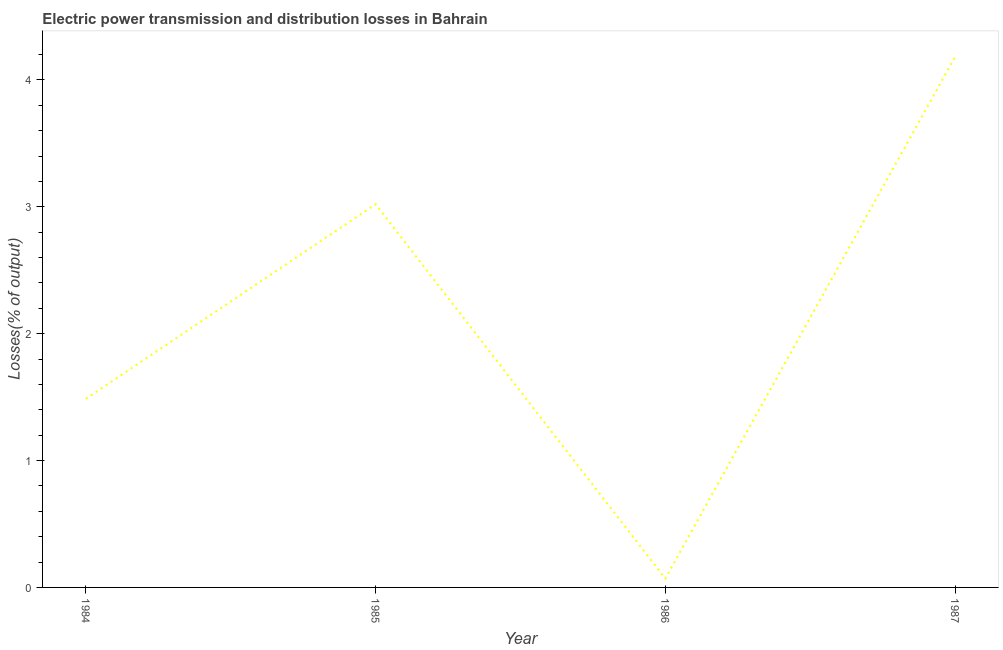What is the electric power transmission and distribution losses in 1984?
Your response must be concise. 1.49. Across all years, what is the maximum electric power transmission and distribution losses?
Provide a succinct answer. 4.18. Across all years, what is the minimum electric power transmission and distribution losses?
Offer a terse response. 0.07. In which year was the electric power transmission and distribution losses maximum?
Your response must be concise. 1987. In which year was the electric power transmission and distribution losses minimum?
Provide a short and direct response. 1986. What is the sum of the electric power transmission and distribution losses?
Your response must be concise. 8.76. What is the difference between the electric power transmission and distribution losses in 1984 and 1985?
Offer a terse response. -1.53. What is the average electric power transmission and distribution losses per year?
Your answer should be compact. 2.19. What is the median electric power transmission and distribution losses?
Keep it short and to the point. 2.25. In how many years, is the electric power transmission and distribution losses greater than 2.6 %?
Give a very brief answer. 2. What is the ratio of the electric power transmission and distribution losses in 1985 to that in 1987?
Offer a terse response. 0.72. Is the difference between the electric power transmission and distribution losses in 1985 and 1986 greater than the difference between any two years?
Your response must be concise. No. What is the difference between the highest and the second highest electric power transmission and distribution losses?
Your answer should be compact. 1.16. Is the sum of the electric power transmission and distribution losses in 1984 and 1986 greater than the maximum electric power transmission and distribution losses across all years?
Provide a short and direct response. No. What is the difference between the highest and the lowest electric power transmission and distribution losses?
Your answer should be very brief. 4.11. In how many years, is the electric power transmission and distribution losses greater than the average electric power transmission and distribution losses taken over all years?
Make the answer very short. 2. Does the electric power transmission and distribution losses monotonically increase over the years?
Keep it short and to the point. No. Does the graph contain grids?
Provide a succinct answer. No. What is the title of the graph?
Make the answer very short. Electric power transmission and distribution losses in Bahrain. What is the label or title of the Y-axis?
Offer a very short reply. Losses(% of output). What is the Losses(% of output) in 1984?
Offer a terse response. 1.49. What is the Losses(% of output) of 1985?
Give a very brief answer. 3.02. What is the Losses(% of output) of 1986?
Keep it short and to the point. 0.07. What is the Losses(% of output) in 1987?
Ensure brevity in your answer.  4.18. What is the difference between the Losses(% of output) in 1984 and 1985?
Provide a short and direct response. -1.53. What is the difference between the Losses(% of output) in 1984 and 1986?
Provide a succinct answer. 1.42. What is the difference between the Losses(% of output) in 1984 and 1987?
Your response must be concise. -2.7. What is the difference between the Losses(% of output) in 1985 and 1986?
Ensure brevity in your answer.  2.95. What is the difference between the Losses(% of output) in 1985 and 1987?
Your response must be concise. -1.16. What is the difference between the Losses(% of output) in 1986 and 1987?
Your answer should be compact. -4.11. What is the ratio of the Losses(% of output) in 1984 to that in 1985?
Your response must be concise. 0.49. What is the ratio of the Losses(% of output) in 1984 to that in 1986?
Your answer should be compact. 21.21. What is the ratio of the Losses(% of output) in 1984 to that in 1987?
Ensure brevity in your answer.  0.35. What is the ratio of the Losses(% of output) in 1985 to that in 1986?
Keep it short and to the point. 43.1. What is the ratio of the Losses(% of output) in 1985 to that in 1987?
Offer a terse response. 0.72. What is the ratio of the Losses(% of output) in 1986 to that in 1987?
Provide a succinct answer. 0.02. 